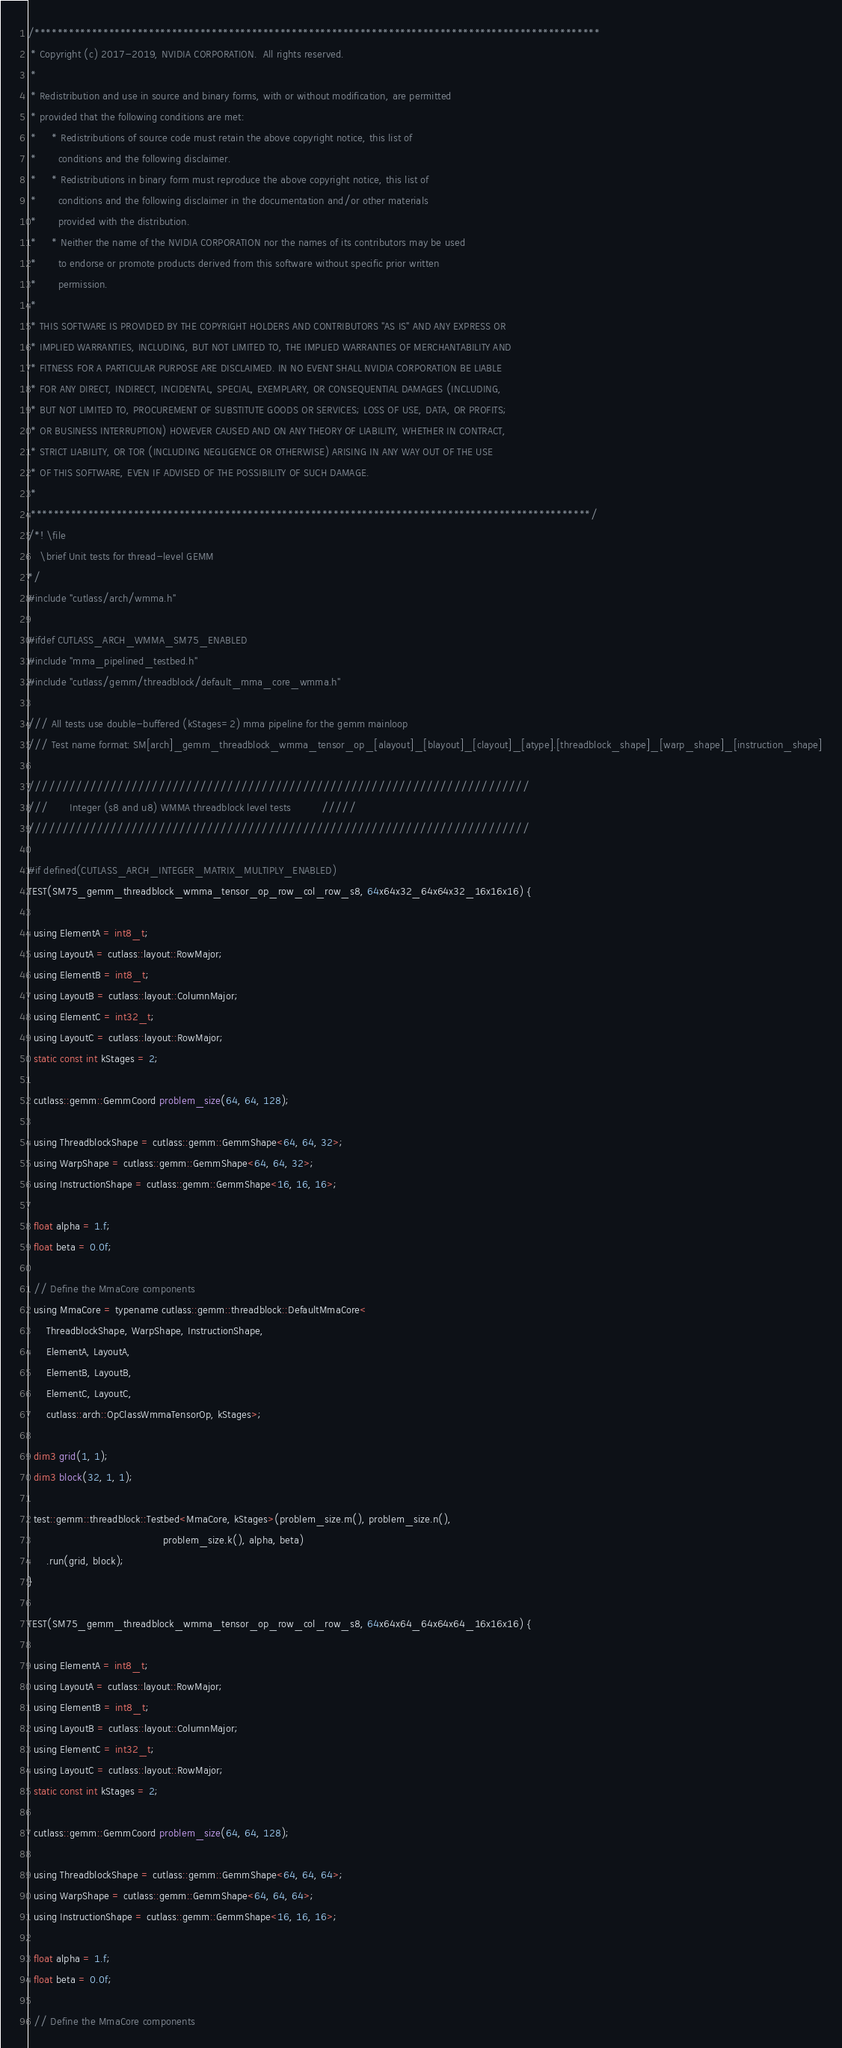<code> <loc_0><loc_0><loc_500><loc_500><_Cuda_>/***************************************************************************************************
 * Copyright (c) 2017-2019, NVIDIA CORPORATION.  All rights reserved.
 *
 * Redistribution and use in source and binary forms, with or without modification, are permitted
 * provided that the following conditions are met:
 *     * Redistributions of source code must retain the above copyright notice, this list of
 *       conditions and the following disclaimer.
 *     * Redistributions in binary form must reproduce the above copyright notice, this list of
 *       conditions and the following disclaimer in the documentation and/or other materials
 *       provided with the distribution.
 *     * Neither the name of the NVIDIA CORPORATION nor the names of its contributors may be used
 *       to endorse or promote products derived from this software without specific prior written
 *       permission.
 *
 * THIS SOFTWARE IS PROVIDED BY THE COPYRIGHT HOLDERS AND CONTRIBUTORS "AS IS" AND ANY EXPRESS OR
 * IMPLIED WARRANTIES, INCLUDING, BUT NOT LIMITED TO, THE IMPLIED WARRANTIES OF MERCHANTABILITY AND
 * FITNESS FOR A PARTICULAR PURPOSE ARE DISCLAIMED. IN NO EVENT SHALL NVIDIA CORPORATION BE LIABLE
 * FOR ANY DIRECT, INDIRECT, INCIDENTAL, SPECIAL, EXEMPLARY, OR CONSEQUENTIAL DAMAGES (INCLUDING,
 * BUT NOT LIMITED TO, PROCUREMENT OF SUBSTITUTE GOODS OR SERVICES; LOSS OF USE, DATA, OR PROFITS;
 * OR BUSINESS INTERRUPTION) HOWEVER CAUSED AND ON ANY THEORY OF LIABILITY, WHETHER IN CONTRACT,
 * STRICT LIABILITY, OR TOR (INCLUDING NEGLIGENCE OR OTHERWISE) ARISING IN ANY WAY OUT OF THE USE
 * OF THIS SOFTWARE, EVEN IF ADVISED OF THE POSSIBILITY OF SUCH DAMAGE.
 *
 **************************************************************************************************/
/*! \file
    \brief Unit tests for thread-level GEMM
*/
#include "cutlass/arch/wmma.h"

#ifdef CUTLASS_ARCH_WMMA_SM75_ENABLED
#include "mma_pipelined_testbed.h"
#include "cutlass/gemm/threadblock/default_mma_core_wmma.h"

/// All tests use double-buffered (kStages=2) mma pipeline for the gemm mainloop
/// Test name format: SM[arch]_gemm_threadblock_wmma_tensor_op_[alayout]_[blayout]_[clayout]_[atype].[threadblock_shape]_[warp_shape]_[instruction_shape]

/////////////////////////////////////////////////////////////////////////
///       Integer (s8 and u8) WMMA threadblock level tests          /////
/////////////////////////////////////////////////////////////////////////

#if defined(CUTLASS_ARCH_INTEGER_MATRIX_MULTIPLY_ENABLED)
TEST(SM75_gemm_threadblock_wmma_tensor_op_row_col_row_s8, 64x64x32_64x64x32_16x16x16) {
 
  using ElementA = int8_t;
  using LayoutA = cutlass::layout::RowMajor;
  using ElementB = int8_t;
  using LayoutB = cutlass::layout::ColumnMajor;
  using ElementC = int32_t;
  using LayoutC = cutlass::layout::RowMajor;
  static const int kStages = 2; 

  cutlass::gemm::GemmCoord problem_size(64, 64, 128);

  using ThreadblockShape = cutlass::gemm::GemmShape<64, 64, 32>;
  using WarpShape = cutlass::gemm::GemmShape<64, 64, 32>;
  using InstructionShape = cutlass::gemm::GemmShape<16, 16, 16>;

  float alpha = 1.f;
  float beta = 0.0f;

  // Define the MmaCore components
  using MmaCore = typename cutlass::gemm::threadblock::DefaultMmaCore<
      ThreadblockShape, WarpShape, InstructionShape, 
      ElementA, LayoutA,
      ElementB, LayoutB, 
      ElementC, LayoutC,
      cutlass::arch::OpClassWmmaTensorOp, kStages>;

  dim3 grid(1, 1);
  dim3 block(32, 1, 1);

  test::gemm::threadblock::Testbed<MmaCore, kStages>(problem_size.m(), problem_size.n(),
                                            problem_size.k(), alpha, beta)
      .run(grid, block);
}

TEST(SM75_gemm_threadblock_wmma_tensor_op_row_col_row_s8, 64x64x64_64x64x64_16x16x16) {
 
  using ElementA = int8_t;
  using LayoutA = cutlass::layout::RowMajor;
  using ElementB = int8_t;
  using LayoutB = cutlass::layout::ColumnMajor;
  using ElementC = int32_t;
  using LayoutC = cutlass::layout::RowMajor;
  static const int kStages = 2; 

  cutlass::gemm::GemmCoord problem_size(64, 64, 128);

  using ThreadblockShape = cutlass::gemm::GemmShape<64, 64, 64>;
  using WarpShape = cutlass::gemm::GemmShape<64, 64, 64>;
  using InstructionShape = cutlass::gemm::GemmShape<16, 16, 16>;

  float alpha = 1.f;
  float beta = 0.0f;

  // Define the MmaCore components</code> 